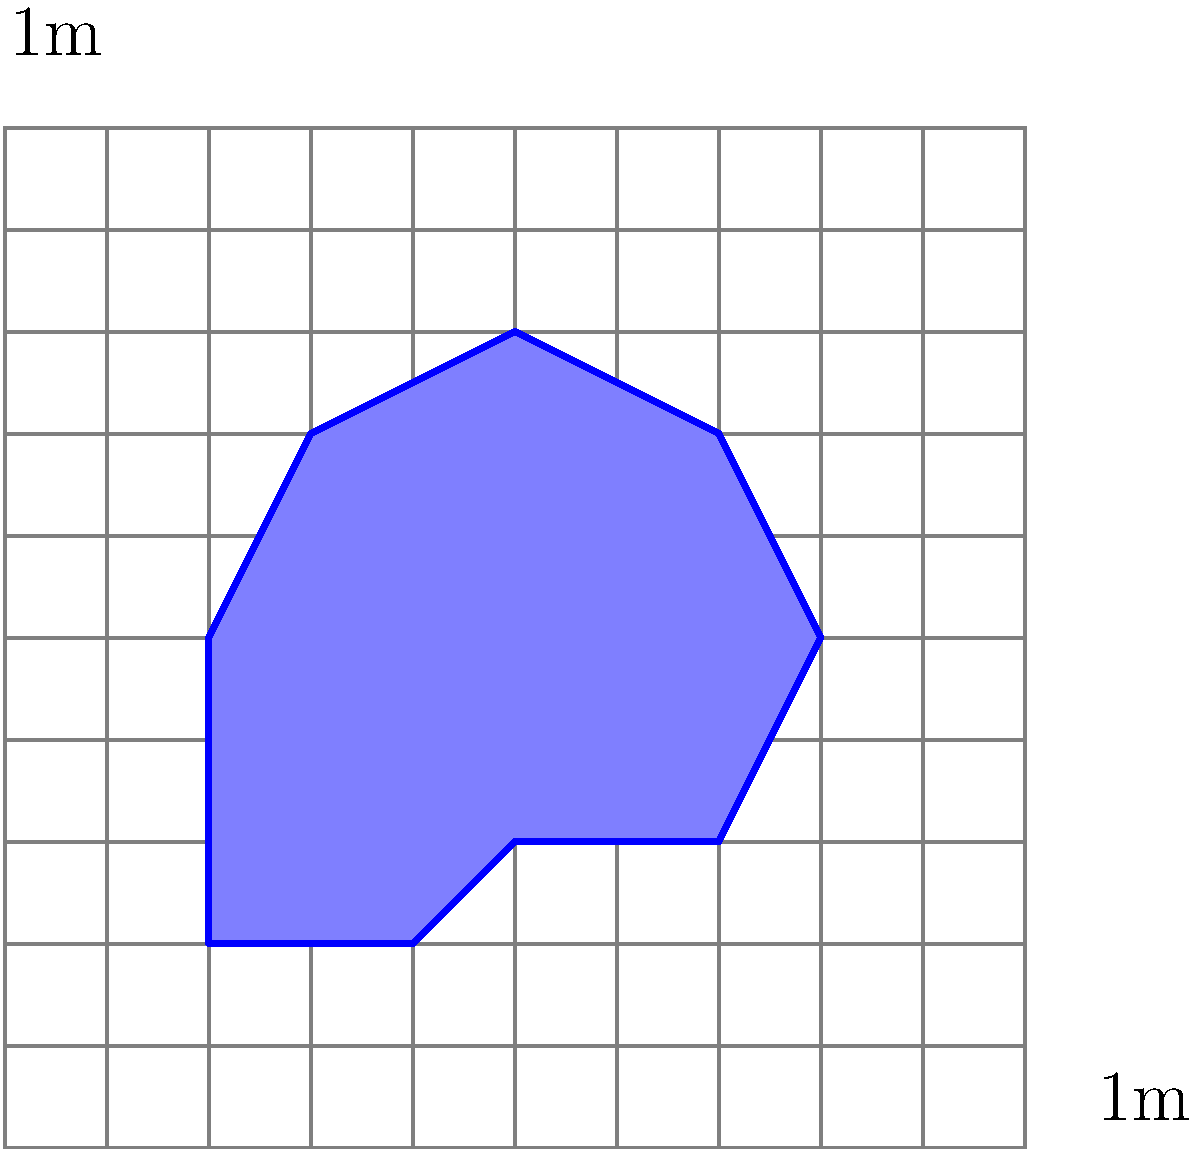A crime scene has an irregular shape as shown in the grid overlay above. Each square in the grid represents 1 square meter. Using the counting squares method, estimate the area of the crime scene to the nearest whole square meter. To estimate the area of the irregular crime scene using the counting squares method, follow these steps:

1. Count the full squares within the shape:
   There are approximately 18 full squares.

2. Count the partial squares:
   There are about 14 partial squares around the edges.

3. Estimate the area of partial squares:
   Assume that, on average, each partial square is about half of a full square.
   So, the area of partial squares is approximately: $14 \times 0.5 = 7$ square meters.

4. Sum up the total area:
   Total area = Full squares + Estimated partial squares
   $$ \text{Total area} = 18 + 7 = 25 \text{ square meters} $$

5. Round to the nearest whole square meter:
   The estimated area is already a whole number, so no rounding is necessary.

Therefore, the estimated area of the crime scene is 25 square meters.
Answer: 25 square meters 